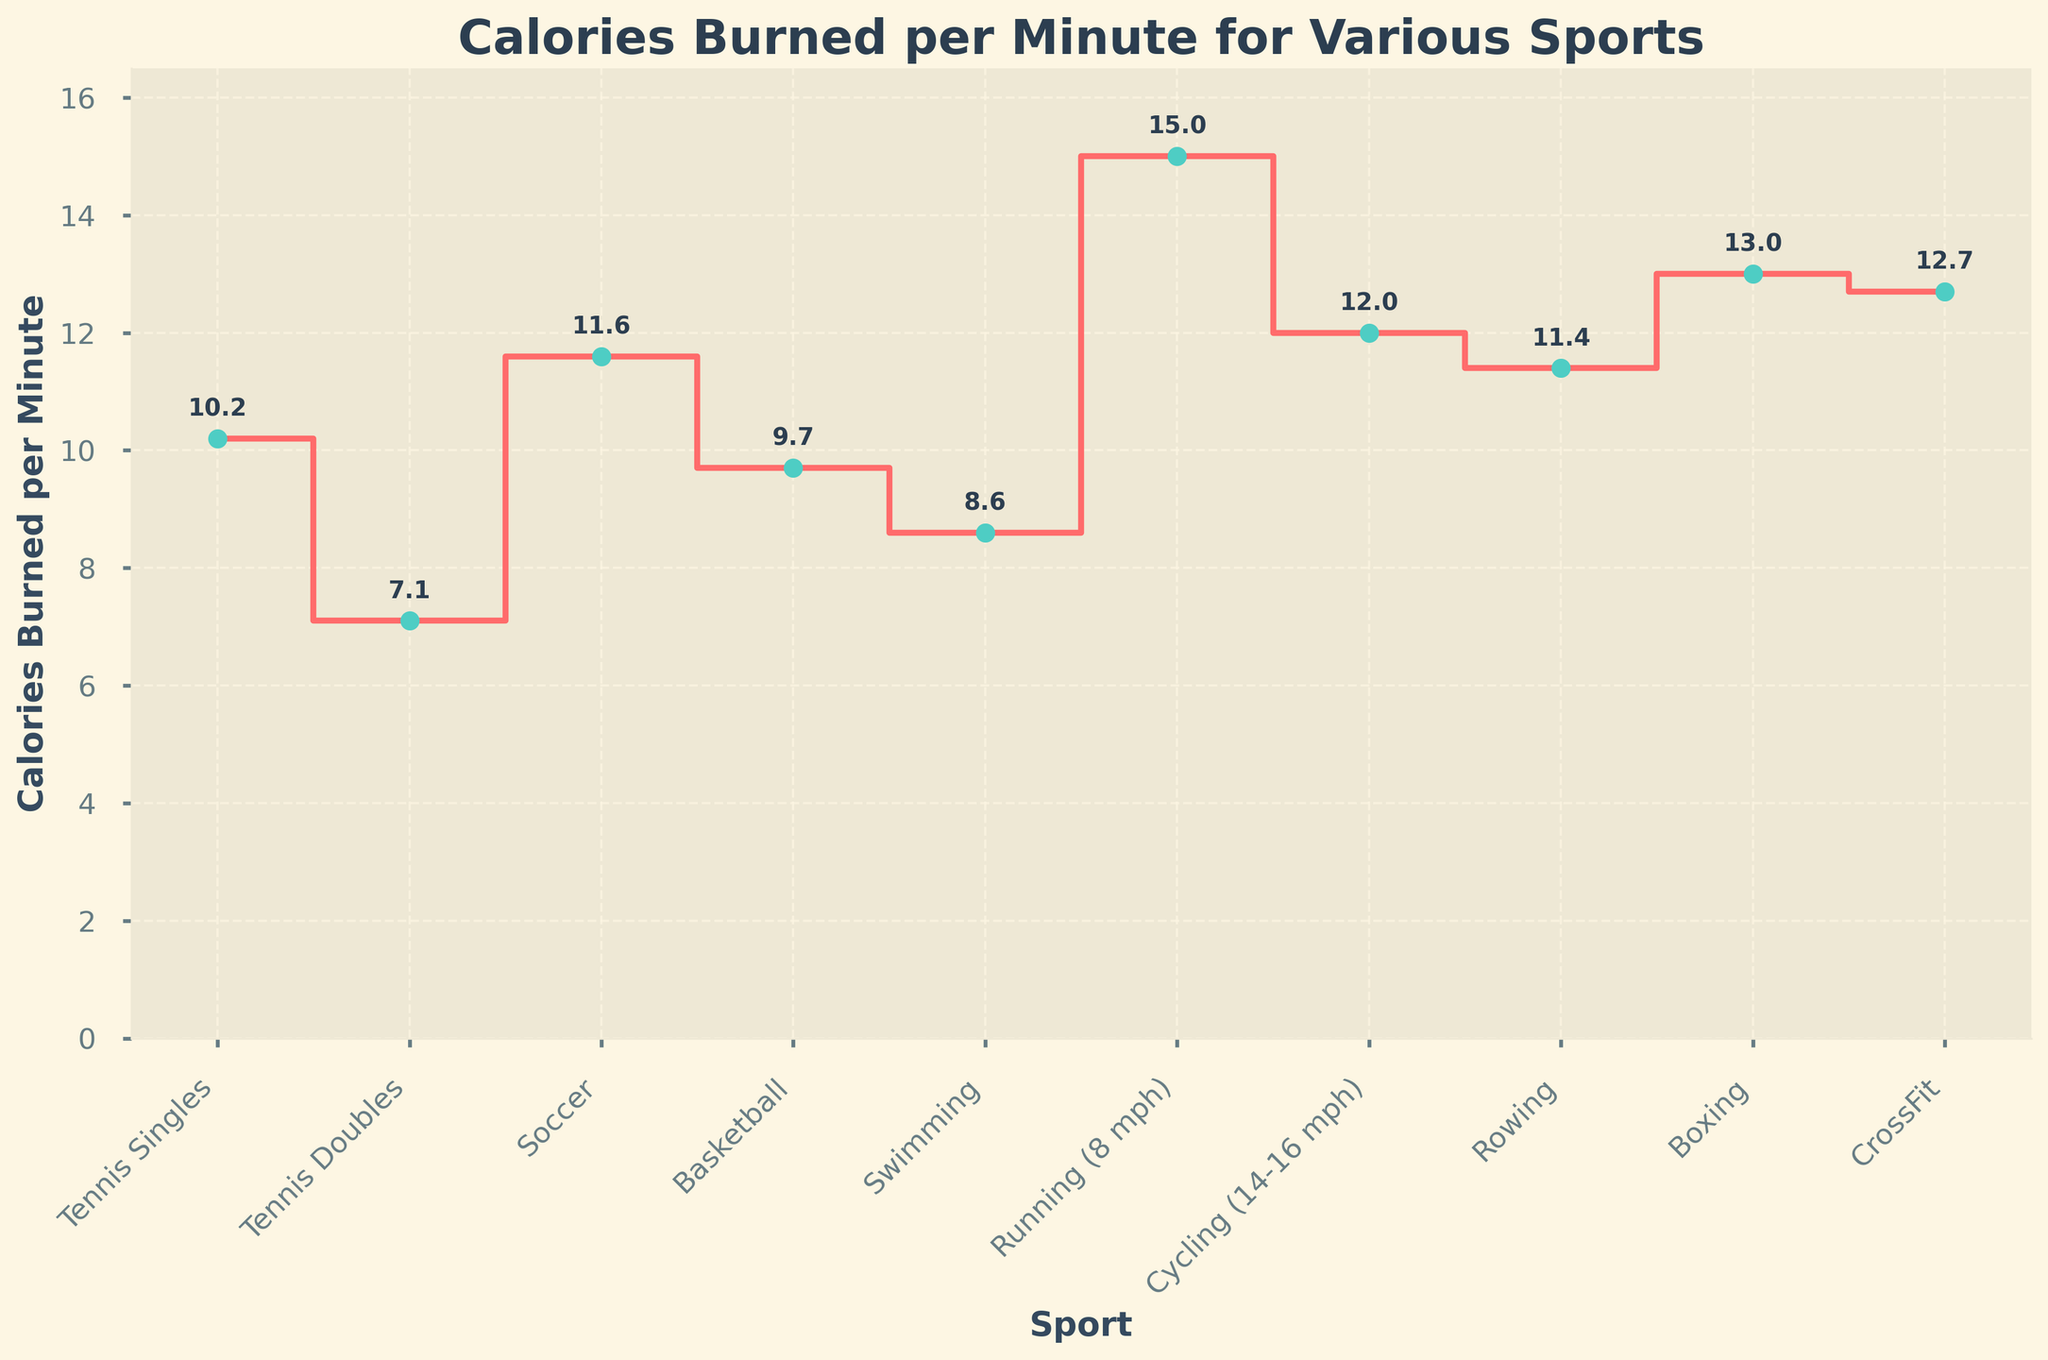What is the title of the plot? The title of the plot is located at the top and provides a description of what the plot represents.
Answer: Calories Burned per Minute for Various Sports What is the maximum value of calories burned per minute and which sport does it correspond to? By looking at the y-axis and identifying the highest value point in the plot, we find the maximum calories burned per minute. This value corresponds to the sport labeled directly below this point on the x-axis.
Answer: 15.0, Running (8 mph) How many sports burn more than 10 calories per minute? Find the points in the plot where the y-axis value is greater than 10 and count these points.
Answer: 5 Which sport burns fewer calories per minute: Tennis Singles or Tennis Doubles? Identify both sports on the x-axis and compare their respective y-axis values to see which is lower.
Answer: Tennis Doubles What is the difference in calories burned per minute between Soccer and Basketball? Locate Soccer and Basketball on the x-axis, find their y-axis values, then subtract the smaller value from the larger one to get the difference.
Answer: 1.9 Which sport has the lowest calories burned per minute and what is the value? Identify the lowest point on the y-axis and note the corresponding sport on the x-axis and its value.
Answer: Tennis Doubles, 7.1 On average, how many calories are burned per minute across all sports? Sum up all calorie values from each sport and divide by the number of sports to get the average. There are 10 sports. Sum is \(10.2 + 7.1 + 11.6 + 9.7 + 8.6 + 15.0 + 12.0 + 11.4 + 13.0 + 12.7 = 111.3\). The average is \(111.3 / 10 = 11.13\).
Answer: 11.13 What is the midpoint value of the calories burned per minute for the listed sports? Order the calorie values from lowest to highest and find the middle value. Since there are 10 points, the midpoint is the average of the 5th and 6th values when ordered. The ordered values are \(7.1, 8.6, 9.7, 10.2, 11.4, 11.6, 12.0, 12.7, 13.0, 15.0\). The midpoint is \((11.4 + 11.6) / 2 = 11.5\).
Answer: 11.5 Which sport shows a dramatic increase in calories burned per minute compared to Swimming? Locate Swimming on the x-axis (8.6 calories) and look for a sport with a significantly higher y-axis value. Running (8 mph) burns 15.0 calories. The difference is 15.0 - 8.6 = 6.4, a substantial increase.
Answer: Running (8 mph) 